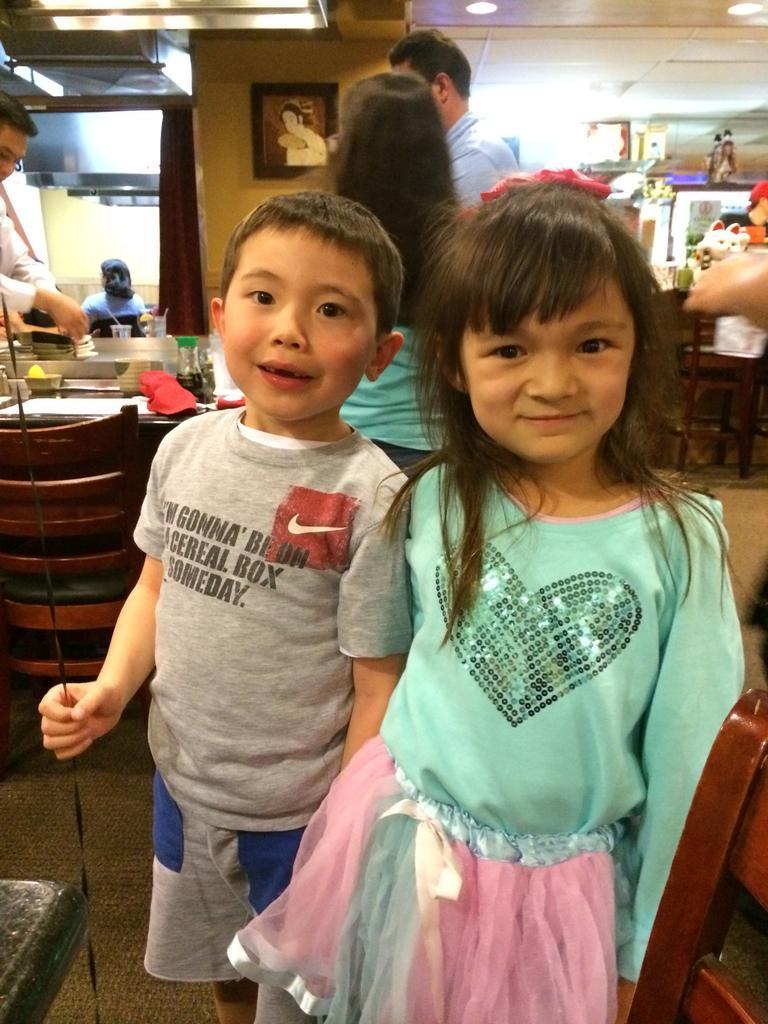Describe this image in one or two sentences. In this image we can see a boy holding a black color rope and we can also see a girl smiling. Image also consists of toys, frames, glass, jar and also paper. We can also see a table with a chair. At the top there is roof for shelter. Lights are also visible. 